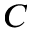Convert formula to latex. <formula><loc_0><loc_0><loc_500><loc_500>C</formula> 